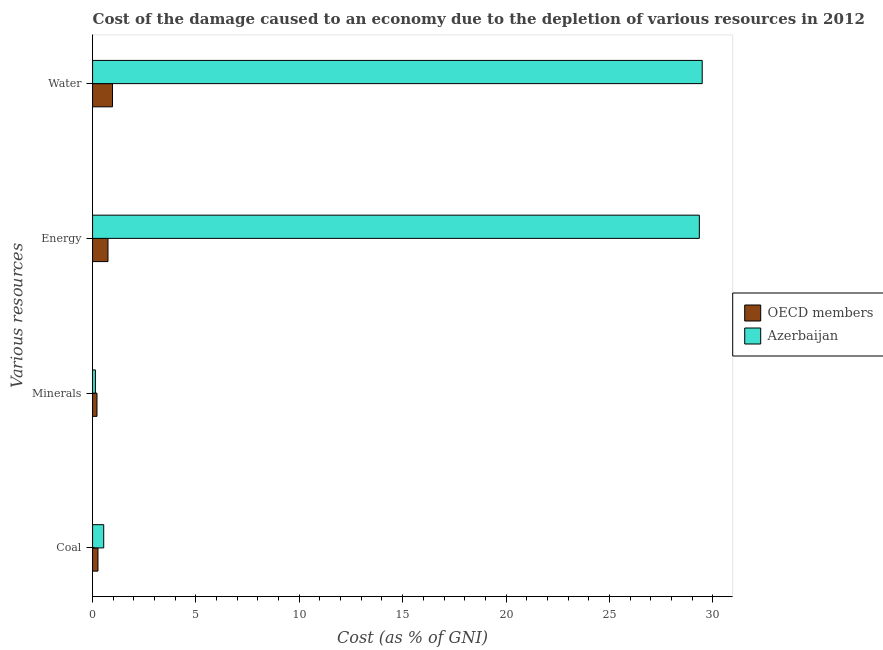How many different coloured bars are there?
Keep it short and to the point. 2. How many groups of bars are there?
Give a very brief answer. 4. How many bars are there on the 1st tick from the top?
Give a very brief answer. 2. What is the label of the 1st group of bars from the top?
Keep it short and to the point. Water. What is the cost of damage due to depletion of minerals in OECD members?
Provide a short and direct response. 0.21. Across all countries, what is the maximum cost of damage due to depletion of energy?
Ensure brevity in your answer.  29.35. Across all countries, what is the minimum cost of damage due to depletion of water?
Make the answer very short. 0.96. In which country was the cost of damage due to depletion of energy maximum?
Give a very brief answer. Azerbaijan. What is the total cost of damage due to depletion of water in the graph?
Offer a very short reply. 30.45. What is the difference between the cost of damage due to depletion of energy in OECD members and that in Azerbaijan?
Keep it short and to the point. -28.61. What is the difference between the cost of damage due to depletion of water in OECD members and the cost of damage due to depletion of minerals in Azerbaijan?
Give a very brief answer. 0.83. What is the average cost of damage due to depletion of energy per country?
Your response must be concise. 15.05. What is the difference between the cost of damage due to depletion of coal and cost of damage due to depletion of water in Azerbaijan?
Give a very brief answer. -28.95. What is the ratio of the cost of damage due to depletion of minerals in Azerbaijan to that in OECD members?
Ensure brevity in your answer.  0.65. Is the cost of damage due to depletion of minerals in OECD members less than that in Azerbaijan?
Make the answer very short. No. What is the difference between the highest and the second highest cost of damage due to depletion of coal?
Provide a short and direct response. 0.28. What is the difference between the highest and the lowest cost of damage due to depletion of water?
Offer a terse response. 28.53. In how many countries, is the cost of damage due to depletion of energy greater than the average cost of damage due to depletion of energy taken over all countries?
Keep it short and to the point. 1. What does the 1st bar from the top in Water represents?
Provide a short and direct response. Azerbaijan. What does the 2nd bar from the bottom in Energy represents?
Your answer should be very brief. Azerbaijan. How many countries are there in the graph?
Offer a terse response. 2. What is the difference between two consecutive major ticks on the X-axis?
Give a very brief answer. 5. Does the graph contain grids?
Your answer should be compact. No. Where does the legend appear in the graph?
Offer a terse response. Center right. What is the title of the graph?
Offer a terse response. Cost of the damage caused to an economy due to the depletion of various resources in 2012 . Does "St. Lucia" appear as one of the legend labels in the graph?
Keep it short and to the point. No. What is the label or title of the X-axis?
Offer a terse response. Cost (as % of GNI). What is the label or title of the Y-axis?
Your answer should be very brief. Various resources. What is the Cost (as % of GNI) in OECD members in Coal?
Provide a succinct answer. 0.26. What is the Cost (as % of GNI) of Azerbaijan in Coal?
Provide a short and direct response. 0.54. What is the Cost (as % of GNI) in OECD members in Minerals?
Ensure brevity in your answer.  0.21. What is the Cost (as % of GNI) of Azerbaijan in Minerals?
Offer a terse response. 0.14. What is the Cost (as % of GNI) in OECD members in Energy?
Ensure brevity in your answer.  0.75. What is the Cost (as % of GNI) of Azerbaijan in Energy?
Ensure brevity in your answer.  29.35. What is the Cost (as % of GNI) in OECD members in Water?
Your response must be concise. 0.96. What is the Cost (as % of GNI) of Azerbaijan in Water?
Ensure brevity in your answer.  29.49. Across all Various resources, what is the maximum Cost (as % of GNI) of OECD members?
Ensure brevity in your answer.  0.96. Across all Various resources, what is the maximum Cost (as % of GNI) in Azerbaijan?
Offer a terse response. 29.49. Across all Various resources, what is the minimum Cost (as % of GNI) in OECD members?
Your answer should be compact. 0.21. Across all Various resources, what is the minimum Cost (as % of GNI) of Azerbaijan?
Give a very brief answer. 0.14. What is the total Cost (as % of GNI) of OECD members in the graph?
Provide a short and direct response. 2.18. What is the total Cost (as % of GNI) of Azerbaijan in the graph?
Offer a very short reply. 59.52. What is the difference between the Cost (as % of GNI) in OECD members in Coal and that in Minerals?
Give a very brief answer. 0.05. What is the difference between the Cost (as % of GNI) of Azerbaijan in Coal and that in Minerals?
Keep it short and to the point. 0.4. What is the difference between the Cost (as % of GNI) in OECD members in Coal and that in Energy?
Your answer should be very brief. -0.48. What is the difference between the Cost (as % of GNI) of Azerbaijan in Coal and that in Energy?
Give a very brief answer. -28.81. What is the difference between the Cost (as % of GNI) of OECD members in Coal and that in Water?
Offer a very short reply. -0.7. What is the difference between the Cost (as % of GNI) in Azerbaijan in Coal and that in Water?
Your answer should be very brief. -28.95. What is the difference between the Cost (as % of GNI) of OECD members in Minerals and that in Energy?
Provide a short and direct response. -0.53. What is the difference between the Cost (as % of GNI) in Azerbaijan in Minerals and that in Energy?
Give a very brief answer. -29.21. What is the difference between the Cost (as % of GNI) of OECD members in Minerals and that in Water?
Your answer should be very brief. -0.75. What is the difference between the Cost (as % of GNI) in Azerbaijan in Minerals and that in Water?
Provide a succinct answer. -29.35. What is the difference between the Cost (as % of GNI) in OECD members in Energy and that in Water?
Your answer should be very brief. -0.22. What is the difference between the Cost (as % of GNI) of Azerbaijan in Energy and that in Water?
Offer a terse response. -0.14. What is the difference between the Cost (as % of GNI) of OECD members in Coal and the Cost (as % of GNI) of Azerbaijan in Minerals?
Your answer should be very brief. 0.12. What is the difference between the Cost (as % of GNI) in OECD members in Coal and the Cost (as % of GNI) in Azerbaijan in Energy?
Offer a terse response. -29.09. What is the difference between the Cost (as % of GNI) of OECD members in Coal and the Cost (as % of GNI) of Azerbaijan in Water?
Make the answer very short. -29.23. What is the difference between the Cost (as % of GNI) of OECD members in Minerals and the Cost (as % of GNI) of Azerbaijan in Energy?
Provide a succinct answer. -29.14. What is the difference between the Cost (as % of GNI) in OECD members in Minerals and the Cost (as % of GNI) in Azerbaijan in Water?
Provide a short and direct response. -29.28. What is the difference between the Cost (as % of GNI) of OECD members in Energy and the Cost (as % of GNI) of Azerbaijan in Water?
Make the answer very short. -28.74. What is the average Cost (as % of GNI) in OECD members per Various resources?
Offer a very short reply. 0.55. What is the average Cost (as % of GNI) in Azerbaijan per Various resources?
Offer a terse response. 14.88. What is the difference between the Cost (as % of GNI) of OECD members and Cost (as % of GNI) of Azerbaijan in Coal?
Give a very brief answer. -0.28. What is the difference between the Cost (as % of GNI) of OECD members and Cost (as % of GNI) of Azerbaijan in Minerals?
Your answer should be very brief. 0.08. What is the difference between the Cost (as % of GNI) of OECD members and Cost (as % of GNI) of Azerbaijan in Energy?
Provide a short and direct response. -28.61. What is the difference between the Cost (as % of GNI) in OECD members and Cost (as % of GNI) in Azerbaijan in Water?
Offer a very short reply. -28.53. What is the ratio of the Cost (as % of GNI) in OECD members in Coal to that in Minerals?
Your answer should be compact. 1.22. What is the ratio of the Cost (as % of GNI) in Azerbaijan in Coal to that in Minerals?
Provide a short and direct response. 3.91. What is the ratio of the Cost (as % of GNI) of OECD members in Coal to that in Energy?
Your answer should be compact. 0.35. What is the ratio of the Cost (as % of GNI) of Azerbaijan in Coal to that in Energy?
Make the answer very short. 0.02. What is the ratio of the Cost (as % of GNI) in OECD members in Coal to that in Water?
Give a very brief answer. 0.27. What is the ratio of the Cost (as % of GNI) of Azerbaijan in Coal to that in Water?
Provide a short and direct response. 0.02. What is the ratio of the Cost (as % of GNI) of OECD members in Minerals to that in Energy?
Give a very brief answer. 0.29. What is the ratio of the Cost (as % of GNI) in Azerbaijan in Minerals to that in Energy?
Your response must be concise. 0. What is the ratio of the Cost (as % of GNI) in OECD members in Minerals to that in Water?
Your answer should be compact. 0.22. What is the ratio of the Cost (as % of GNI) of Azerbaijan in Minerals to that in Water?
Your response must be concise. 0. What is the ratio of the Cost (as % of GNI) in OECD members in Energy to that in Water?
Keep it short and to the point. 0.77. What is the difference between the highest and the second highest Cost (as % of GNI) of OECD members?
Your response must be concise. 0.22. What is the difference between the highest and the second highest Cost (as % of GNI) of Azerbaijan?
Your answer should be very brief. 0.14. What is the difference between the highest and the lowest Cost (as % of GNI) in OECD members?
Your answer should be very brief. 0.75. What is the difference between the highest and the lowest Cost (as % of GNI) of Azerbaijan?
Your response must be concise. 29.35. 